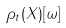<formula> <loc_0><loc_0><loc_500><loc_500>\rho _ { t } ( X ) [ \omega ]</formula> 